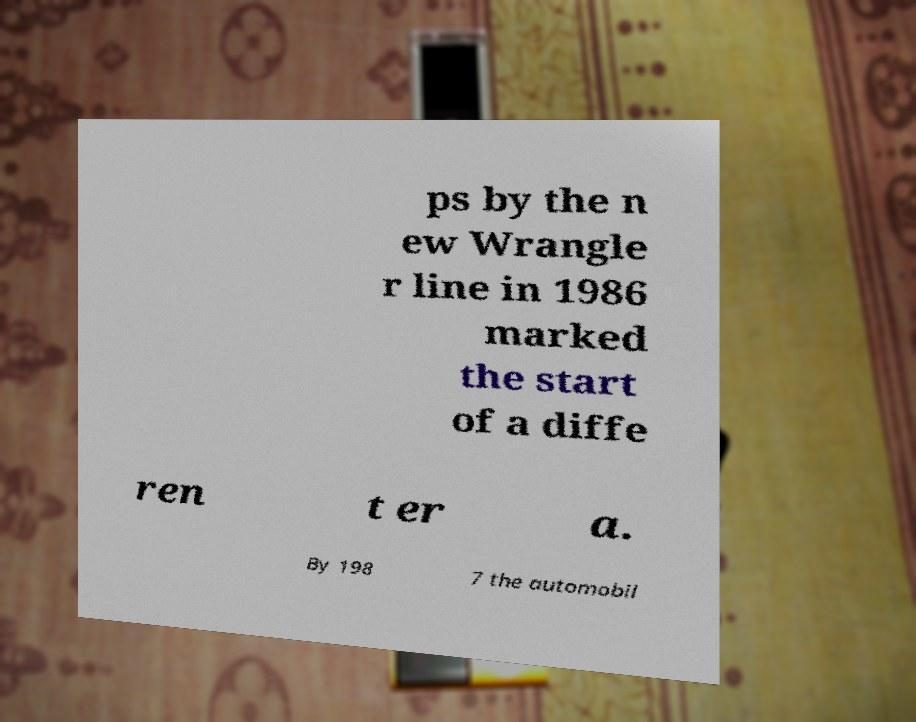Could you extract and type out the text from this image? ps by the n ew Wrangle r line in 1986 marked the start of a diffe ren t er a. By 198 7 the automobil 